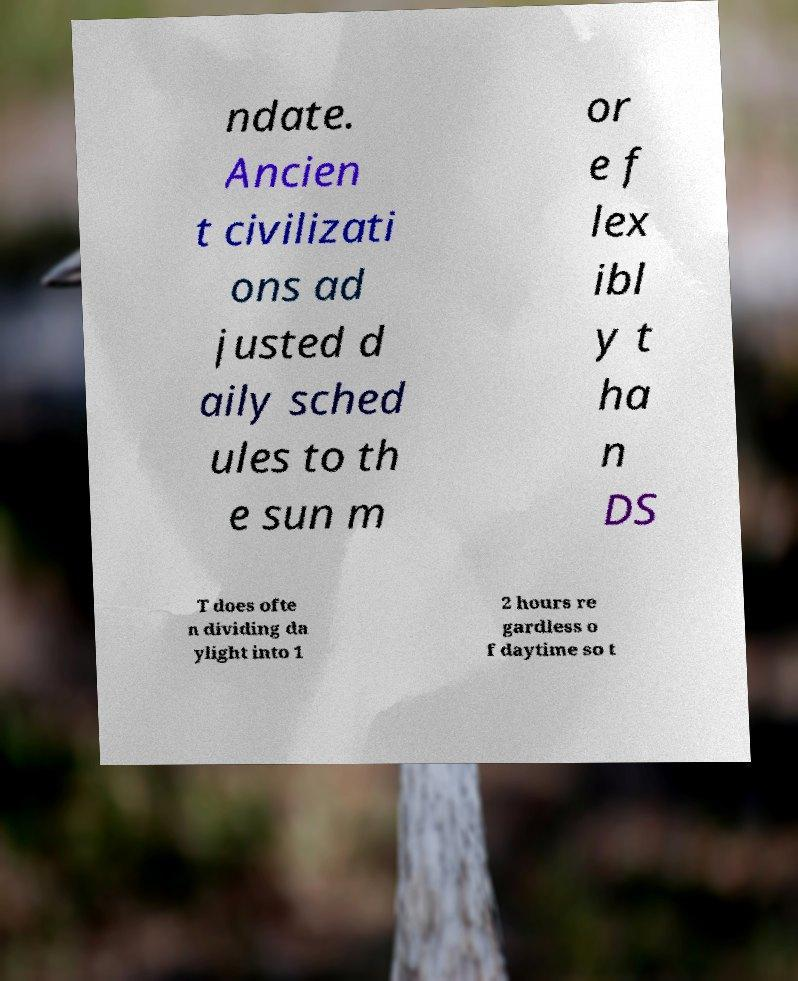Please identify and transcribe the text found in this image. ndate. Ancien t civilizati ons ad justed d aily sched ules to th e sun m or e f lex ibl y t ha n DS T does ofte n dividing da ylight into 1 2 hours re gardless o f daytime so t 